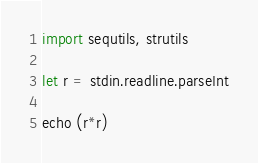<code> <loc_0><loc_0><loc_500><loc_500><_Nim_>import sequtils, strutils

let r = stdin.readline.parseInt

echo (r*r)
</code> 